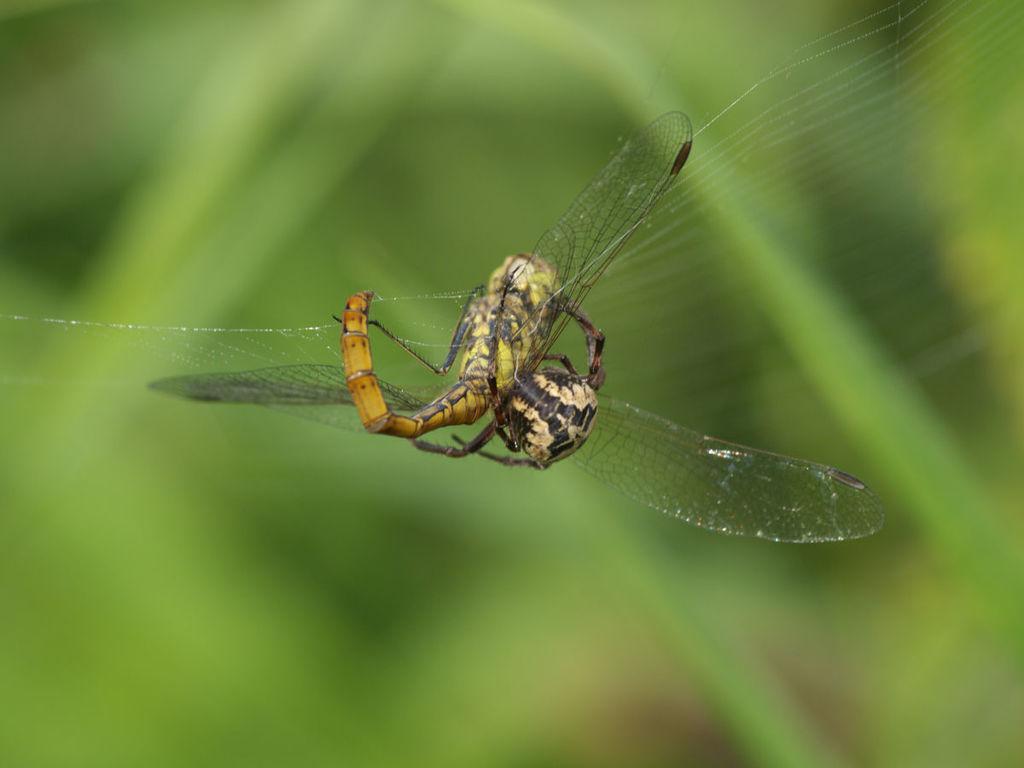How would you summarize this image in a sentence or two? In the center of the image there is a insect. The background of the image is blur. 